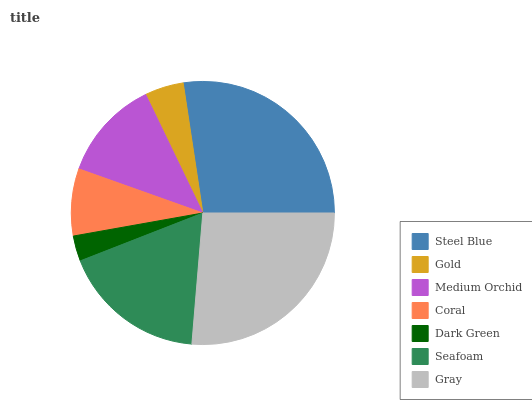Is Dark Green the minimum?
Answer yes or no. Yes. Is Steel Blue the maximum?
Answer yes or no. Yes. Is Gold the minimum?
Answer yes or no. No. Is Gold the maximum?
Answer yes or no. No. Is Steel Blue greater than Gold?
Answer yes or no. Yes. Is Gold less than Steel Blue?
Answer yes or no. Yes. Is Gold greater than Steel Blue?
Answer yes or no. No. Is Steel Blue less than Gold?
Answer yes or no. No. Is Medium Orchid the high median?
Answer yes or no. Yes. Is Medium Orchid the low median?
Answer yes or no. Yes. Is Gray the high median?
Answer yes or no. No. Is Seafoam the low median?
Answer yes or no. No. 